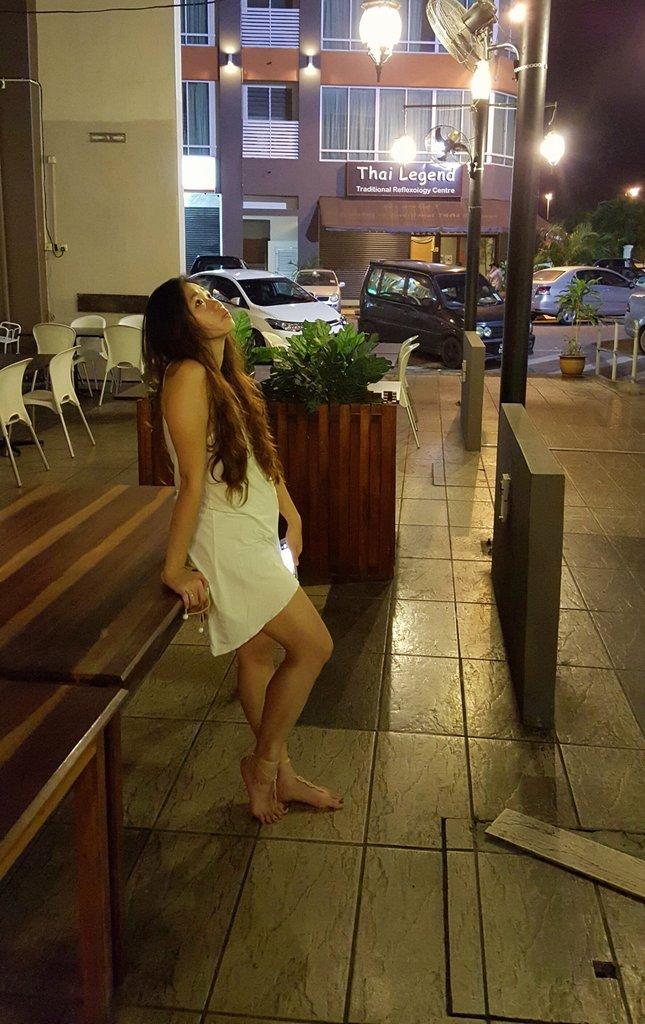In one or two sentences, can you explain what this image depicts? In this image i can see a woman standing at the back ground i can see a small plant, few chairs, a light pole, a board and a building. 